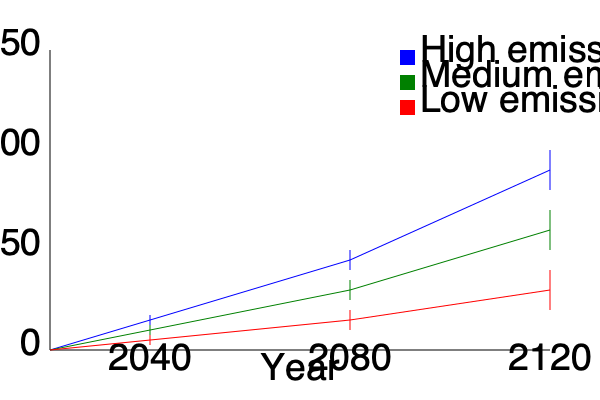Based on the graph showing sea level rise projections under different emission scenarios, what is the approximate range of sea level rise expected by 2080 under the medium emissions scenario? Express your answer in centimeters. To determine the range of sea level rise expected by 2080 under the medium emissions scenario, we need to follow these steps:

1. Identify the medium emissions scenario line (green) on the graph.
2. Locate the year 2080 on the x-axis.
3. Find the point where the medium emissions line intersects with the 2080 vertical.
4. Observe the confidence interval (vertical line) at this point.
5. Estimate the lower and upper bounds of the confidence interval.

Looking at the graph:
1. The medium emissions scenario is represented by the green line.
2. The year 2080 is marked on the x-axis.
3. The green line intersects with the 2080 vertical at approximately 60 cm on the y-axis.
4. The confidence interval at this point extends from about 50 cm to 70 cm.

Therefore, the range of sea level rise expected by 2080 under the medium emissions scenario is approximately 50-70 cm.
Answer: 50-70 cm 